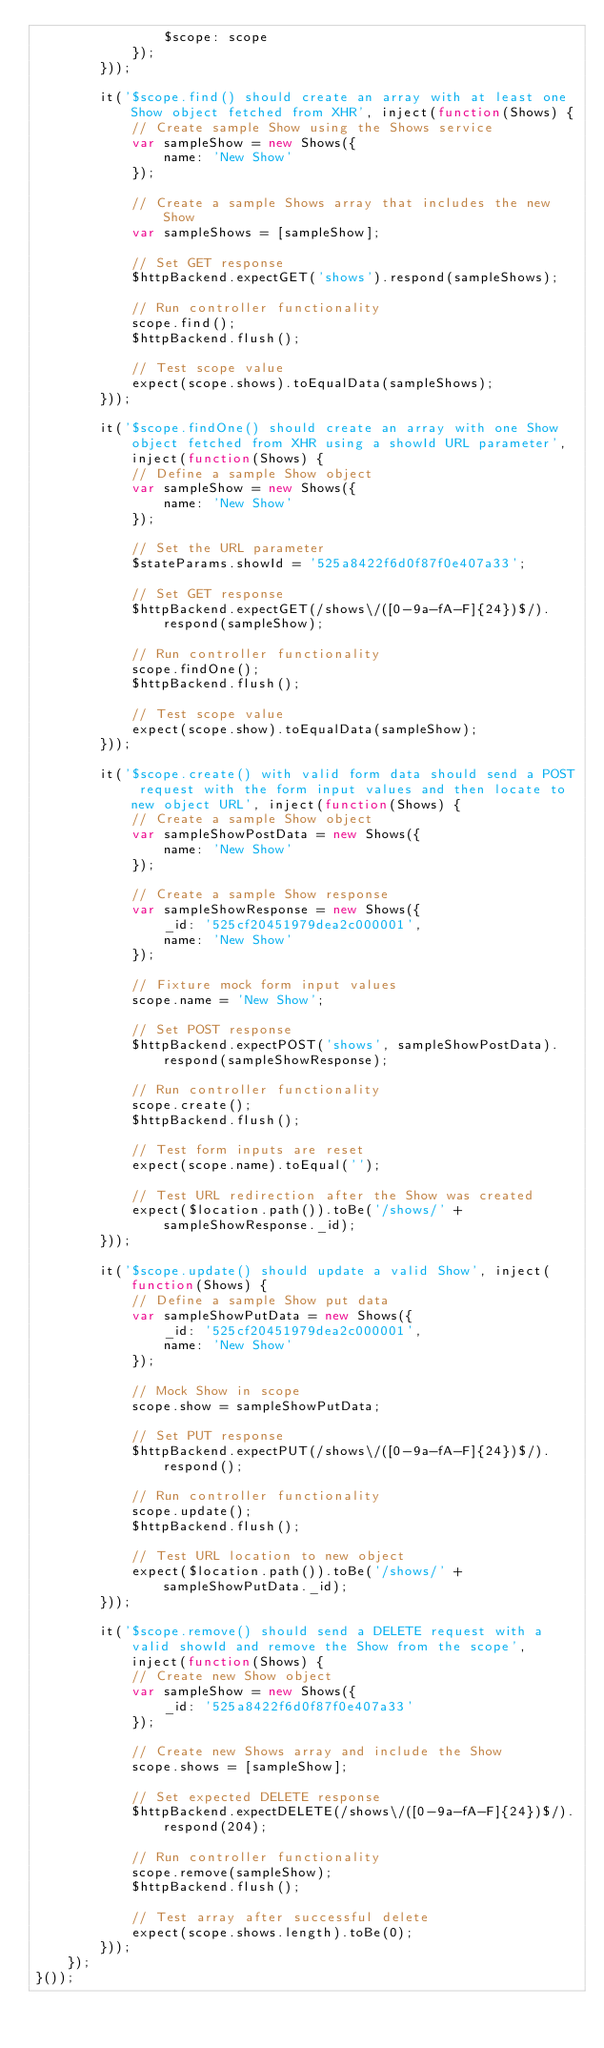<code> <loc_0><loc_0><loc_500><loc_500><_JavaScript_>				$scope: scope
			});
		}));

		it('$scope.find() should create an array with at least one Show object fetched from XHR', inject(function(Shows) {
			// Create sample Show using the Shows service
			var sampleShow = new Shows({
				name: 'New Show'
			});

			// Create a sample Shows array that includes the new Show
			var sampleShows = [sampleShow];

			// Set GET response
			$httpBackend.expectGET('shows').respond(sampleShows);

			// Run controller functionality
			scope.find();
			$httpBackend.flush();

			// Test scope value
			expect(scope.shows).toEqualData(sampleShows);
		}));

		it('$scope.findOne() should create an array with one Show object fetched from XHR using a showId URL parameter', inject(function(Shows) {
			// Define a sample Show object
			var sampleShow = new Shows({
				name: 'New Show'
			});

			// Set the URL parameter
			$stateParams.showId = '525a8422f6d0f87f0e407a33';

			// Set GET response
			$httpBackend.expectGET(/shows\/([0-9a-fA-F]{24})$/).respond(sampleShow);

			// Run controller functionality
			scope.findOne();
			$httpBackend.flush();

			// Test scope value
			expect(scope.show).toEqualData(sampleShow);
		}));

		it('$scope.create() with valid form data should send a POST request with the form input values and then locate to new object URL', inject(function(Shows) {
			// Create a sample Show object
			var sampleShowPostData = new Shows({
				name: 'New Show'
			});

			// Create a sample Show response
			var sampleShowResponse = new Shows({
				_id: '525cf20451979dea2c000001',
				name: 'New Show'
			});

			// Fixture mock form input values
			scope.name = 'New Show';

			// Set POST response
			$httpBackend.expectPOST('shows', sampleShowPostData).respond(sampleShowResponse);

			// Run controller functionality
			scope.create();
			$httpBackend.flush();

			// Test form inputs are reset
			expect(scope.name).toEqual('');

			// Test URL redirection after the Show was created
			expect($location.path()).toBe('/shows/' + sampleShowResponse._id);
		}));

		it('$scope.update() should update a valid Show', inject(function(Shows) {
			// Define a sample Show put data
			var sampleShowPutData = new Shows({
				_id: '525cf20451979dea2c000001',
				name: 'New Show'
			});

			// Mock Show in scope
			scope.show = sampleShowPutData;

			// Set PUT response
			$httpBackend.expectPUT(/shows\/([0-9a-fA-F]{24})$/).respond();

			// Run controller functionality
			scope.update();
			$httpBackend.flush();

			// Test URL location to new object
			expect($location.path()).toBe('/shows/' + sampleShowPutData._id);
		}));

		it('$scope.remove() should send a DELETE request with a valid showId and remove the Show from the scope', inject(function(Shows) {
			// Create new Show object
			var sampleShow = new Shows({
				_id: '525a8422f6d0f87f0e407a33'
			});

			// Create new Shows array and include the Show
			scope.shows = [sampleShow];

			// Set expected DELETE response
			$httpBackend.expectDELETE(/shows\/([0-9a-fA-F]{24})$/).respond(204);

			// Run controller functionality
			scope.remove(sampleShow);
			$httpBackend.flush();

			// Test array after successful delete
			expect(scope.shows.length).toBe(0);
		}));
	});
}());</code> 